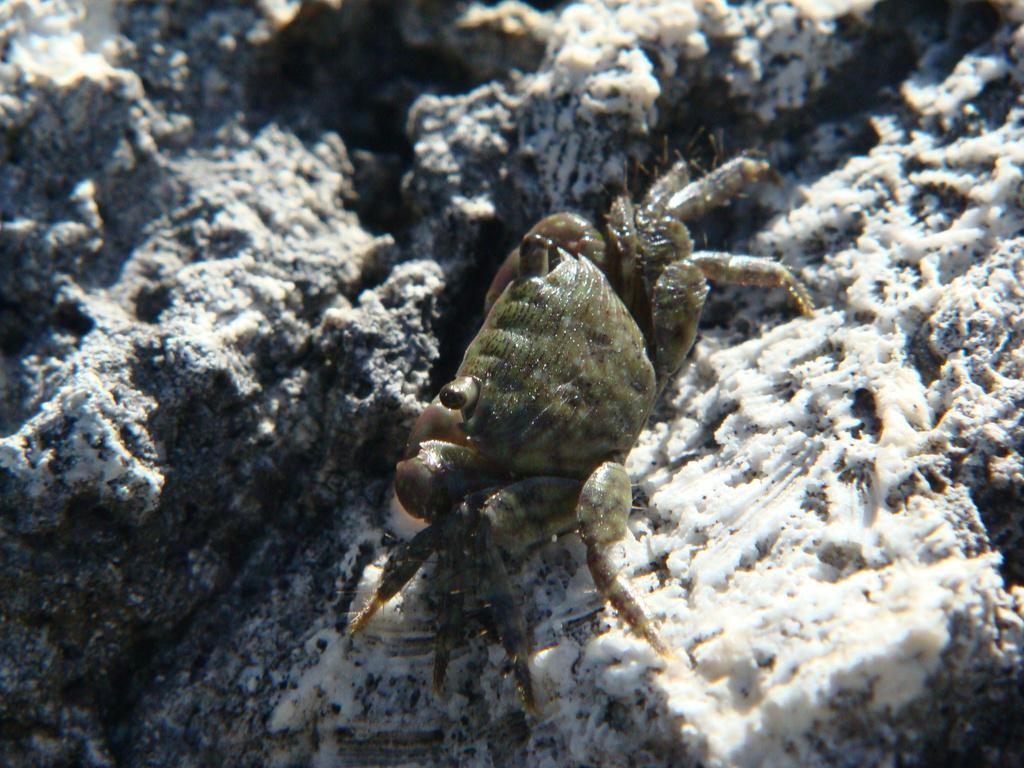What type of animal is in the image? There is a crab in the image. What is the crab's location in the image? The crab is on a rock surface. What type of beef is being cooked on the rock surface in the image? There is no beef present in the image; it only features a crab on a rock surface. 